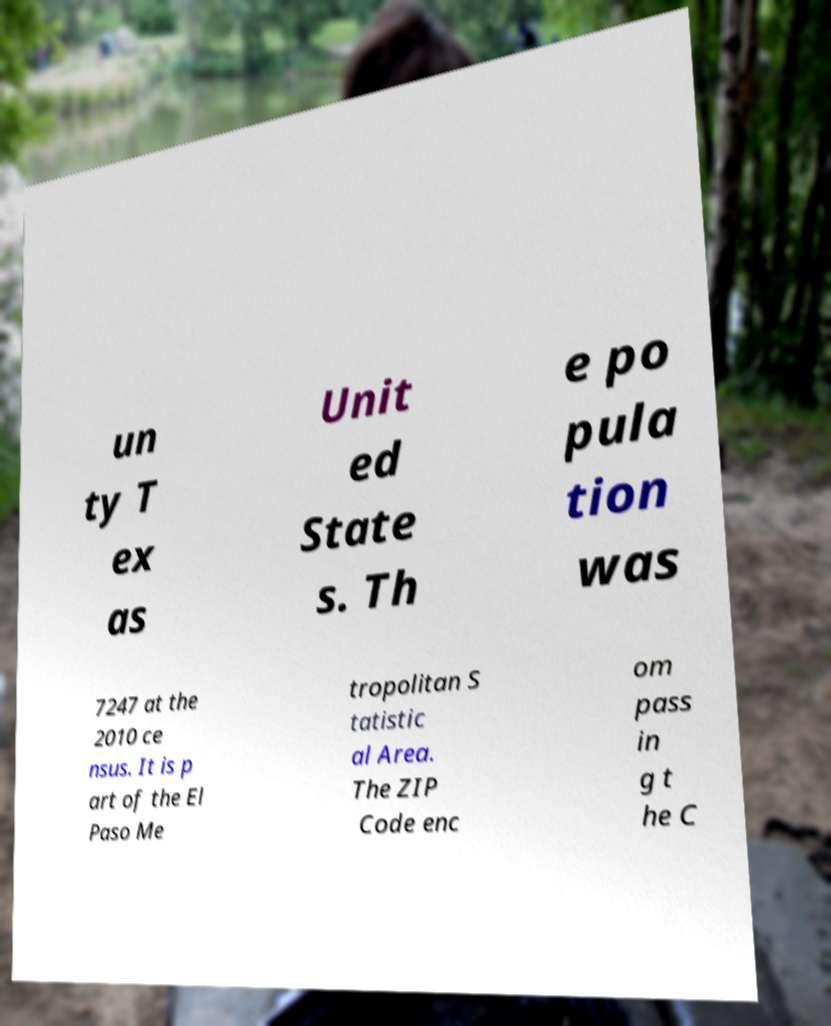Could you assist in decoding the text presented in this image and type it out clearly? un ty T ex as Unit ed State s. Th e po pula tion was 7247 at the 2010 ce nsus. It is p art of the El Paso Me tropolitan S tatistic al Area. The ZIP Code enc om pass in g t he C 